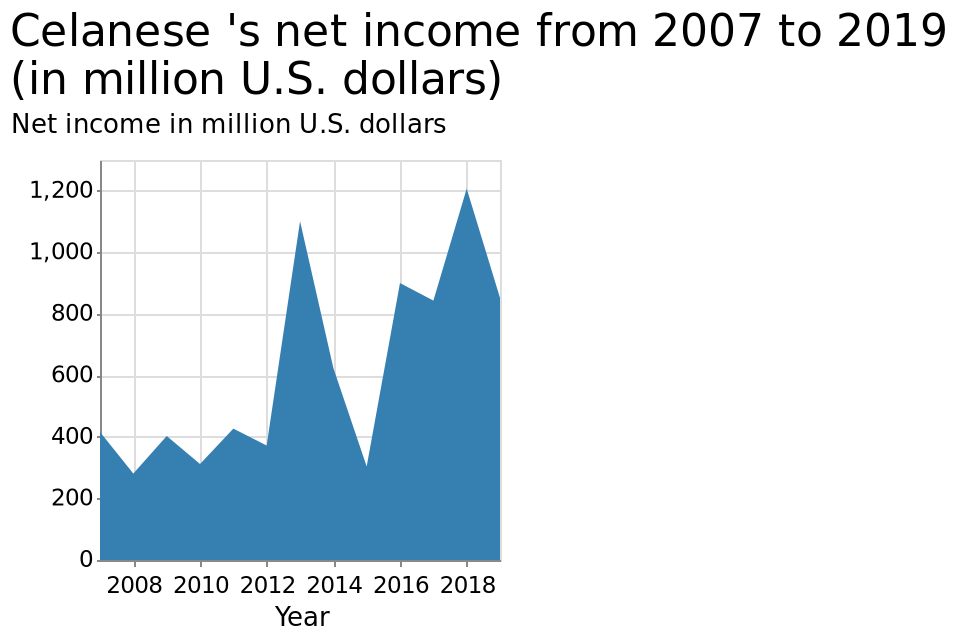<image>
What was Celanese's Net Income in the year 2013?  Celanese's Net Income in 2013 was $1.1 billion. In which year did Celanese's Net Income spike to $1.2 billion?  Celanese's Net Income spiked to $1.2 billion in 2018. How did Celanese's Net Revenue change in 2014 compared to previous years?  Celanese's Net Revenue sharply declined in 2014, reaching similar levels as in 2008 and 2010. 